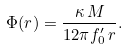Convert formula to latex. <formula><loc_0><loc_0><loc_500><loc_500>\Phi ( r ) = \frac { \kappa \, M } { 1 2 \pi f _ { 0 } ^ { \prime } \, r } .</formula> 